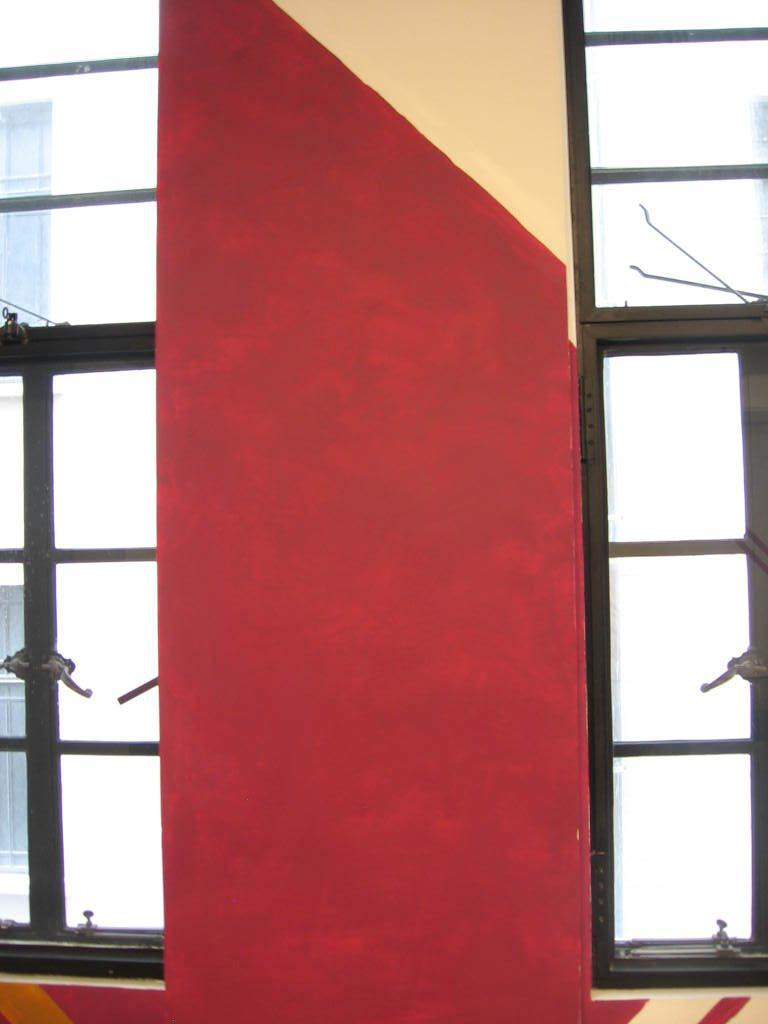What is located in the middle of the image? There is a wall in the middle of the image. Where is the first window located in the image? There is a window on the left side of the image. Where is the second window located in the image? There is a window on the right side of the image. What type of seed can be seen growing on the wall in the image? There is no seed or plant growing on the wall in the image; it is a plain wall. What color is the ink used for writing on the sheet in the image? There is no sheet or writing present in the image. 